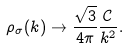<formula> <loc_0><loc_0><loc_500><loc_500>\rho _ { \sigma } ( k ) \to \frac { \sqrt { 3 } } { 4 \pi } \frac { \mathcal { C } } { k ^ { 2 } } .</formula> 